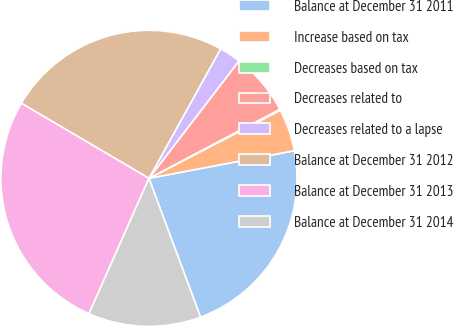Convert chart to OTSL. <chart><loc_0><loc_0><loc_500><loc_500><pie_chart><fcel>Balance at December 31 2011<fcel>Increase based on tax<fcel>Decreases based on tax<fcel>Decreases related to<fcel>Decreases related to a lapse<fcel>Balance at December 31 2012<fcel>Balance at December 31 2013<fcel>Balance at December 31 2014<nl><fcel>22.33%<fcel>4.62%<fcel>0.12%<fcel>6.86%<fcel>2.37%<fcel>24.58%<fcel>26.83%<fcel>12.3%<nl></chart> 